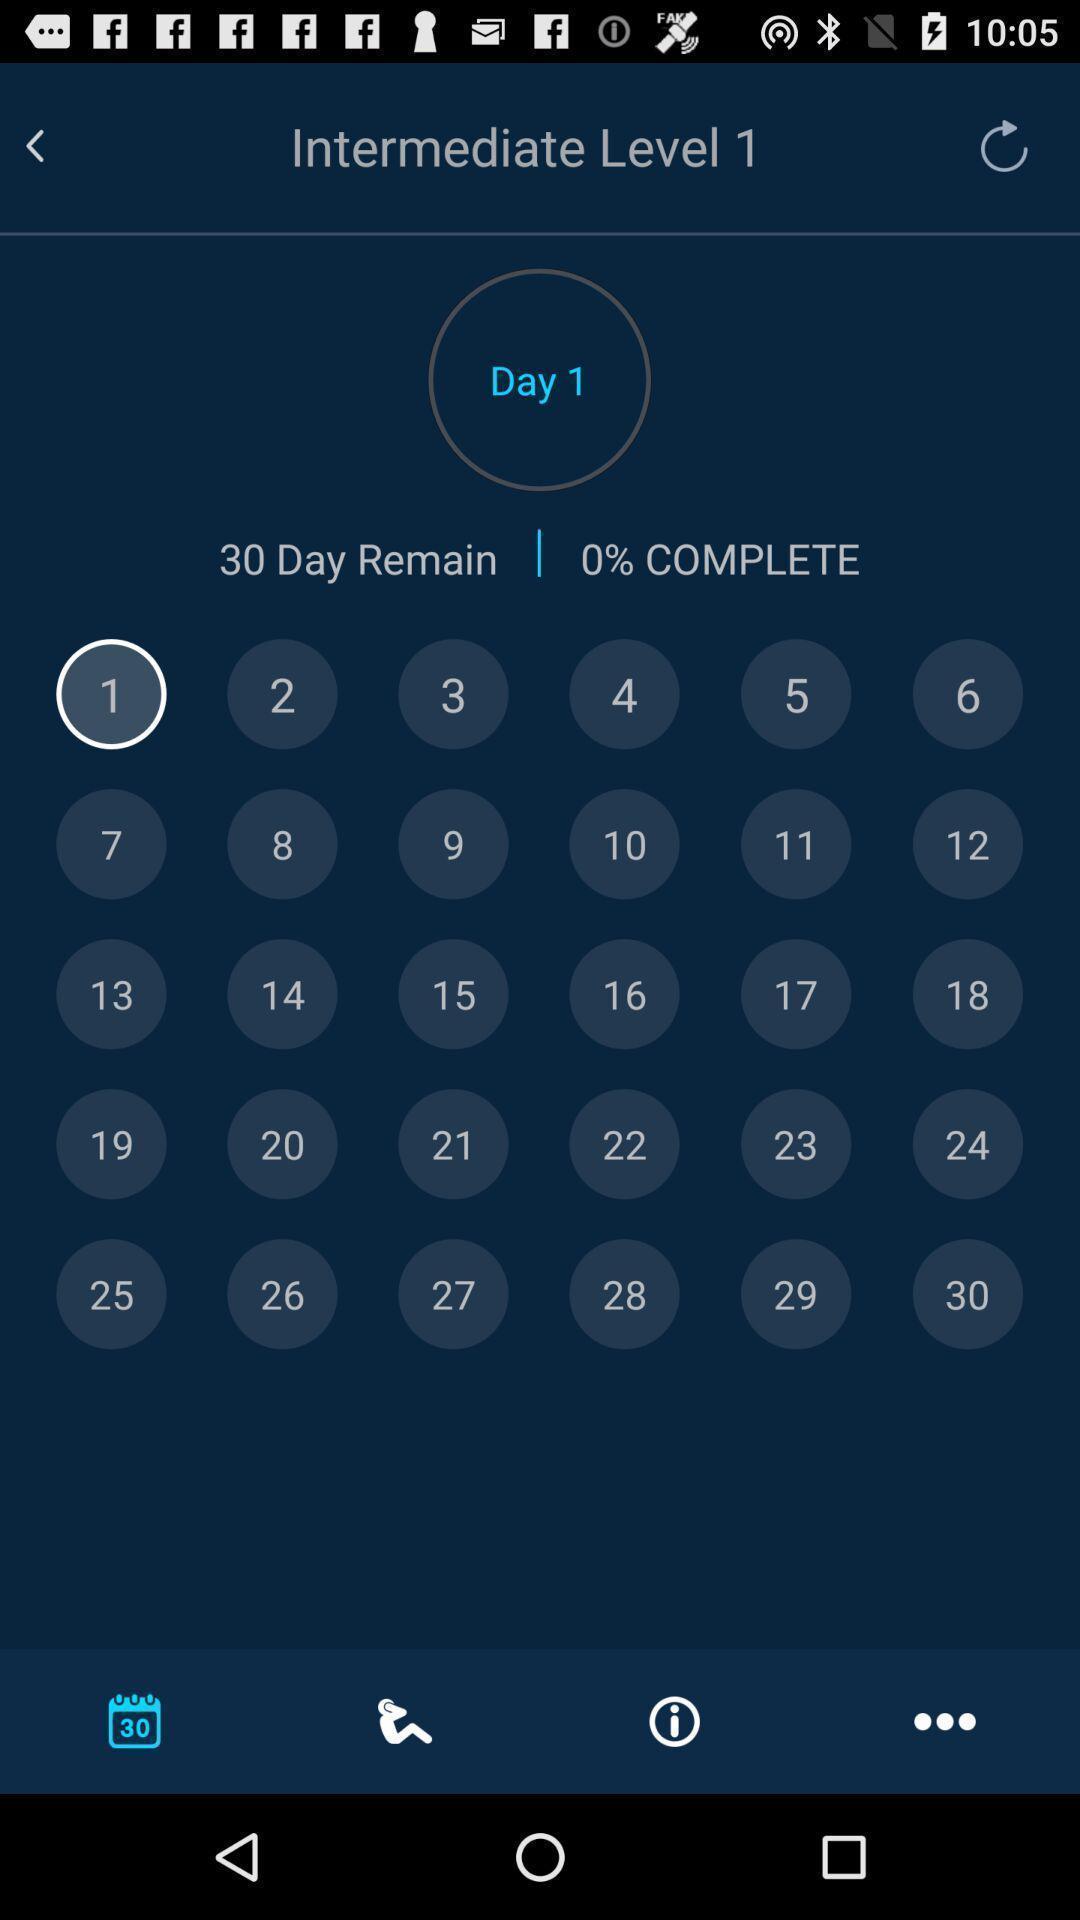What details can you identify in this image? Window displaying days to complete tasks. 